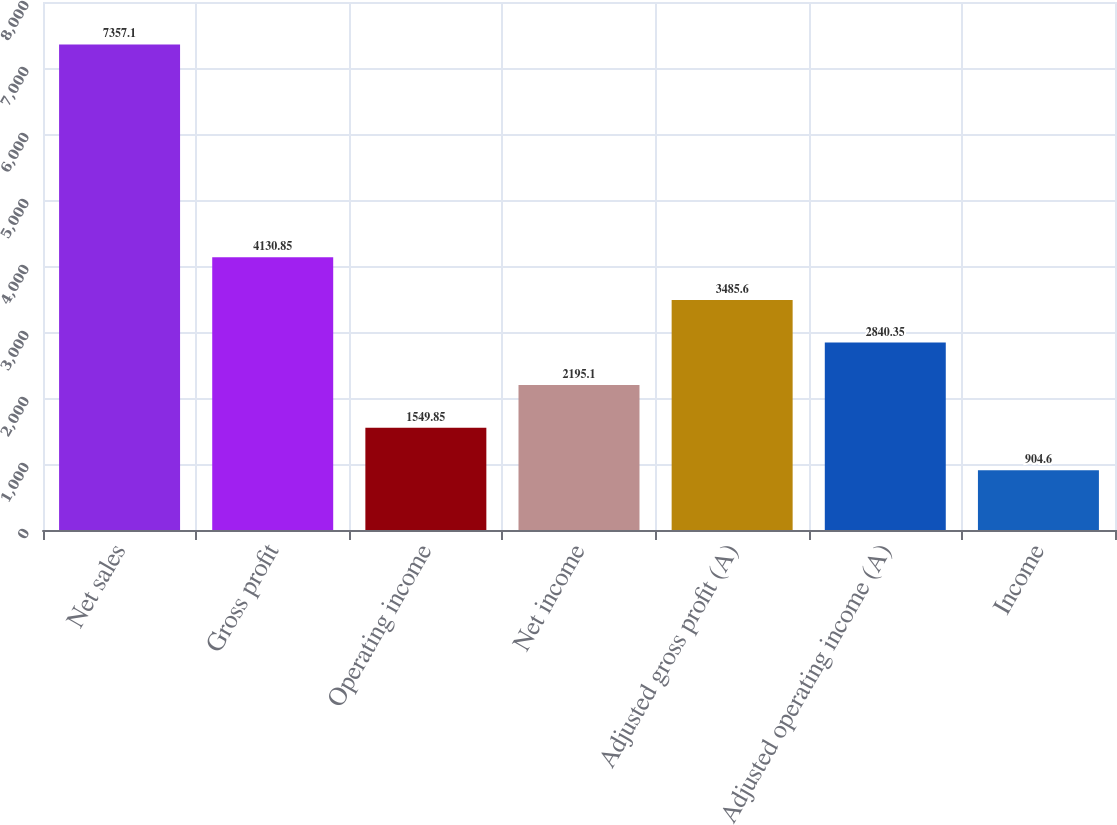<chart> <loc_0><loc_0><loc_500><loc_500><bar_chart><fcel>Net sales<fcel>Gross profit<fcel>Operating income<fcel>Net income<fcel>Adjusted gross profit (A)<fcel>Adjusted operating income (A)<fcel>Income<nl><fcel>7357.1<fcel>4130.85<fcel>1549.85<fcel>2195.1<fcel>3485.6<fcel>2840.35<fcel>904.6<nl></chart> 